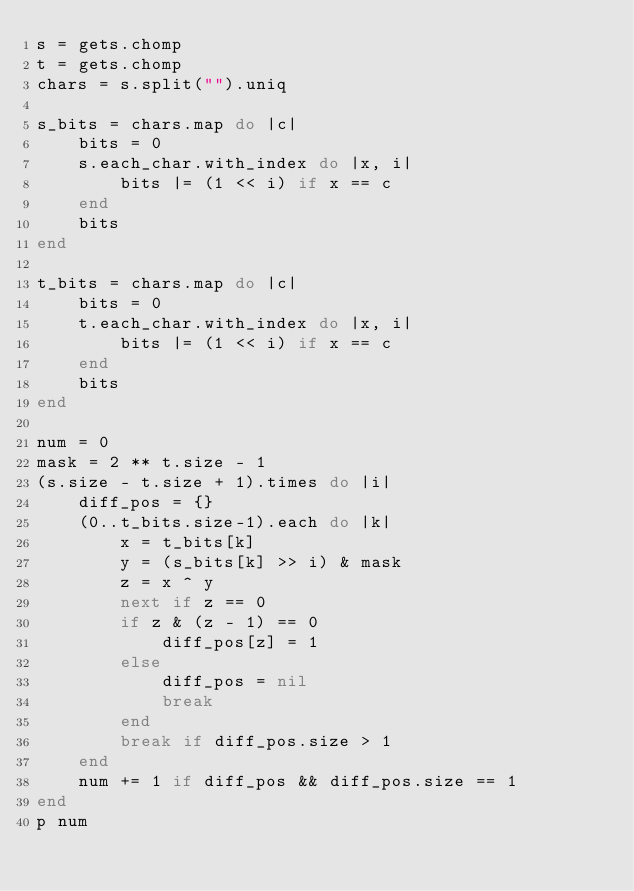<code> <loc_0><loc_0><loc_500><loc_500><_Ruby_>s = gets.chomp
t = gets.chomp
chars = s.split("").uniq

s_bits = chars.map do |c|
    bits = 0
    s.each_char.with_index do |x, i|
        bits |= (1 << i) if x == c
    end
    bits
end

t_bits = chars.map do |c|
    bits = 0
    t.each_char.with_index do |x, i|
        bits |= (1 << i) if x == c
    end
    bits
end

num = 0
mask = 2 ** t.size - 1
(s.size - t.size + 1).times do |i|
    diff_pos = {}
    (0..t_bits.size-1).each do |k|
        x = t_bits[k]
        y = (s_bits[k] >> i) & mask
        z = x ^ y
        next if z == 0
        if z & (z - 1) == 0
            diff_pos[z] = 1
        else
            diff_pos = nil
            break
        end
        break if diff_pos.size > 1
    end
    num += 1 if diff_pos && diff_pos.size == 1
end
p num</code> 